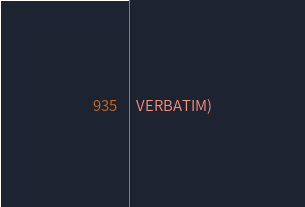<code> <loc_0><loc_0><loc_500><loc_500><_CMake_>  VERBATIM)
</code> 